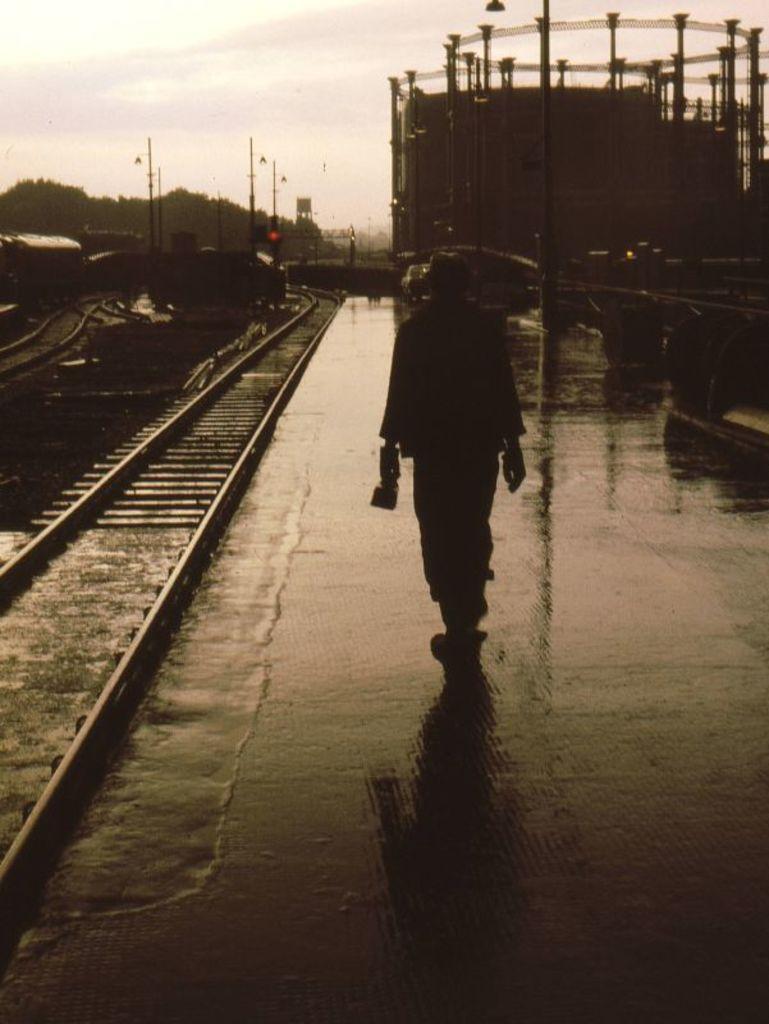Could you give a brief overview of what you see in this image? In the middle of the image a man is walking on platform. Behind him there are some poles and signals. In the bottom left corner of the image there are some tracks. 